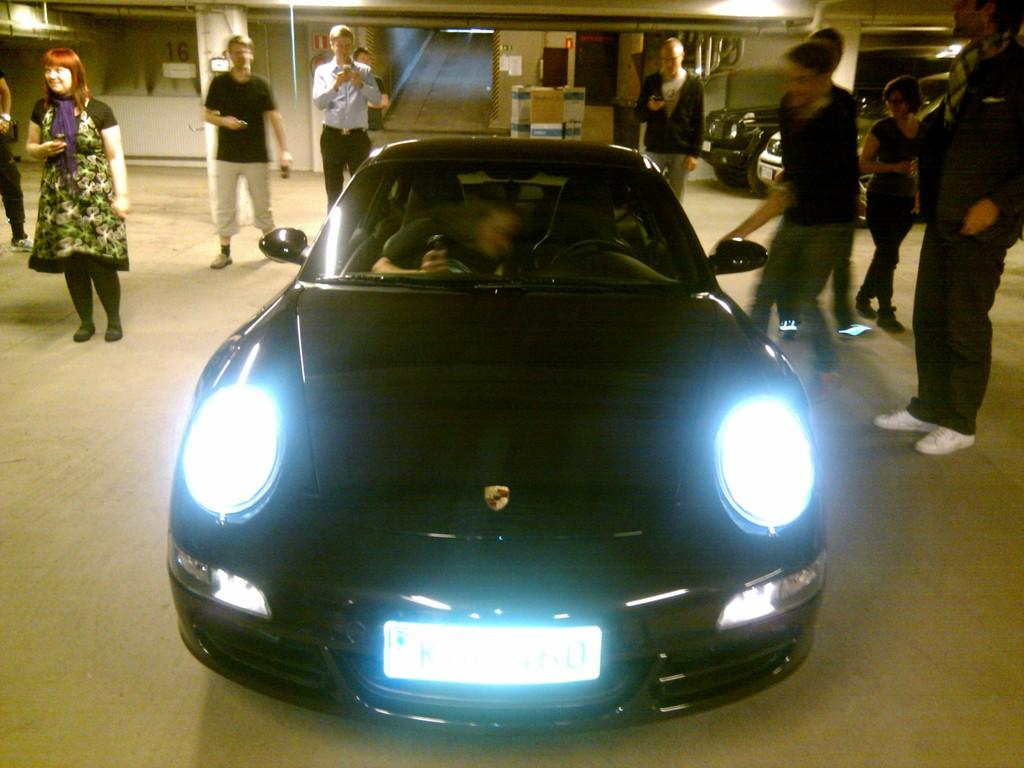What type of car is in the image? There is a black Porsche car in the image. Where is the car located in the image? The car is on the floor. What is the status of the car's headlights? Both headlights of the car are on. What are the people in the background doing? The people in the background are clicking images and staring at the car. What type of shoes are the people wearing while playing with the rock and toys in the image? There are no shoes, rocks, or toys present in the image; it features a black Porsche car with people clicking images and staring at the car. 